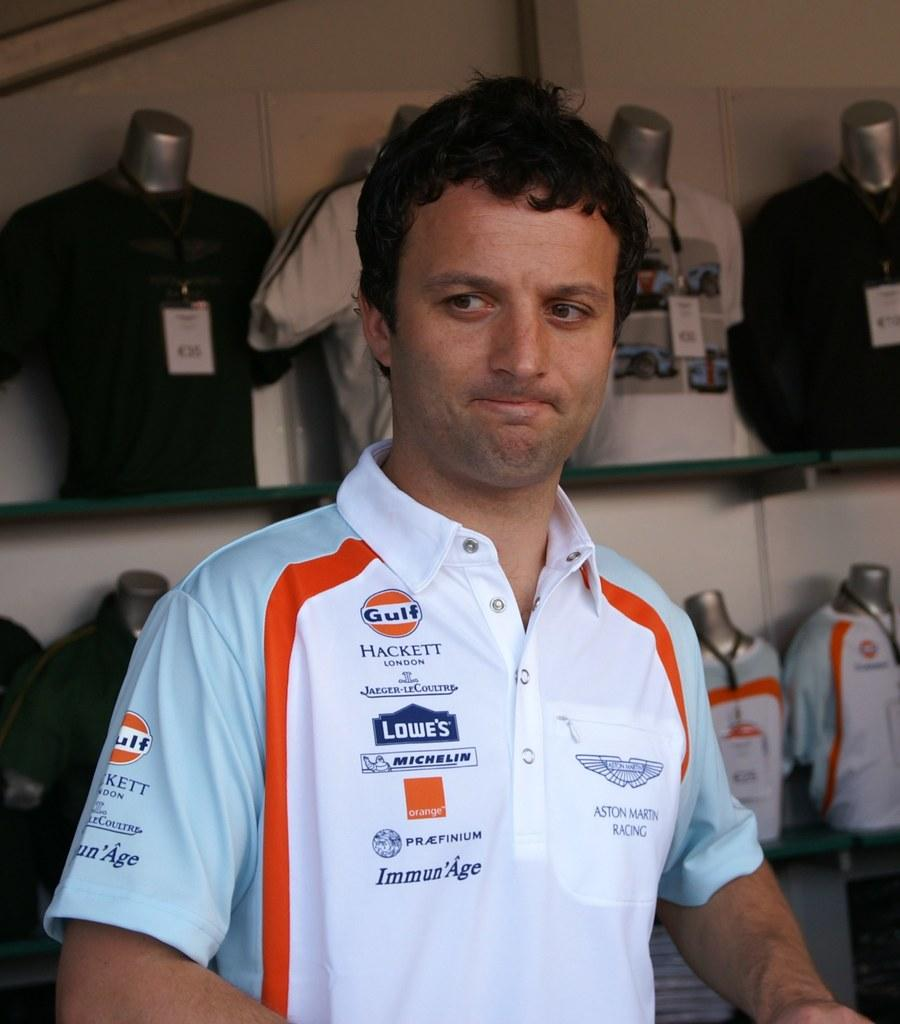<image>
Relay a brief, clear account of the picture shown. A man's shirt includes many logos, including Lowe's and Gulf. 